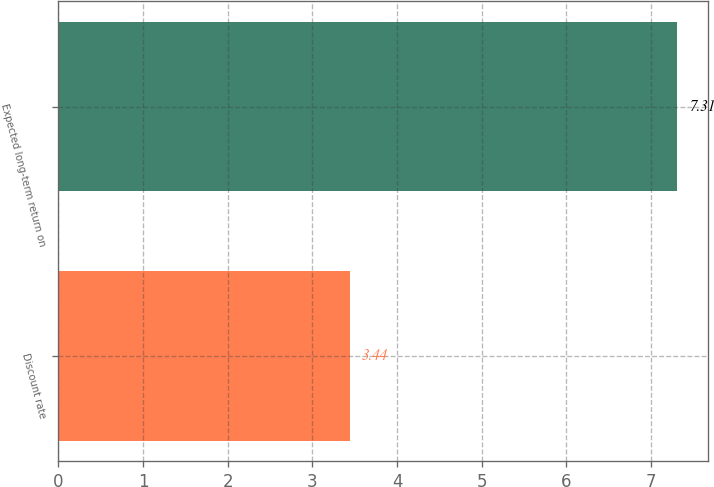Convert chart. <chart><loc_0><loc_0><loc_500><loc_500><bar_chart><fcel>Discount rate<fcel>Expected long-term return on<nl><fcel>3.44<fcel>7.31<nl></chart> 